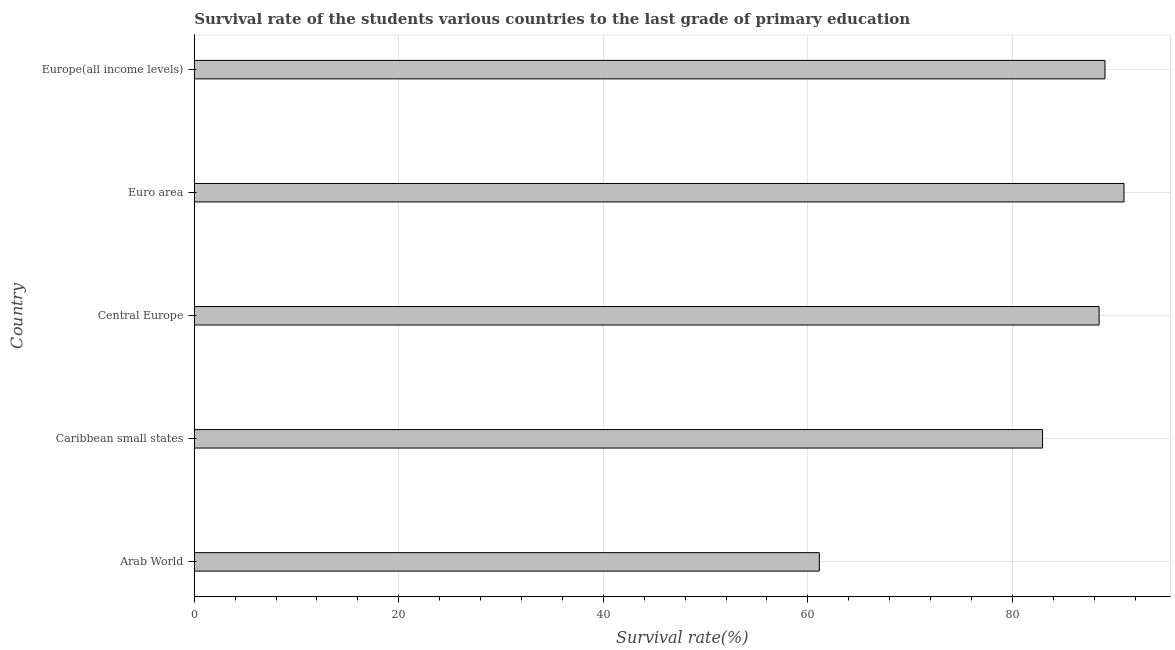Does the graph contain any zero values?
Keep it short and to the point. No. What is the title of the graph?
Provide a succinct answer. Survival rate of the students various countries to the last grade of primary education. What is the label or title of the X-axis?
Your answer should be very brief. Survival rate(%). What is the survival rate in primary education in Caribbean small states?
Ensure brevity in your answer.  82.95. Across all countries, what is the maximum survival rate in primary education?
Ensure brevity in your answer.  90.91. Across all countries, what is the minimum survival rate in primary education?
Give a very brief answer. 61.12. In which country was the survival rate in primary education minimum?
Provide a succinct answer. Arab World. What is the sum of the survival rate in primary education?
Make the answer very short. 412.5. What is the difference between the survival rate in primary education in Caribbean small states and Central Europe?
Your answer should be very brief. -5.53. What is the average survival rate in primary education per country?
Your answer should be compact. 82.5. What is the median survival rate in primary education?
Give a very brief answer. 88.48. In how many countries, is the survival rate in primary education greater than 52 %?
Your answer should be very brief. 5. What is the ratio of the survival rate in primary education in Arab World to that in Europe(all income levels)?
Provide a succinct answer. 0.69. What is the difference between the highest and the second highest survival rate in primary education?
Provide a succinct answer. 1.86. What is the difference between the highest and the lowest survival rate in primary education?
Keep it short and to the point. 29.79. What is the difference between two consecutive major ticks on the X-axis?
Your answer should be very brief. 20. What is the Survival rate(%) of Arab World?
Offer a terse response. 61.12. What is the Survival rate(%) of Caribbean small states?
Offer a terse response. 82.95. What is the Survival rate(%) of Central Europe?
Your response must be concise. 88.48. What is the Survival rate(%) in Euro area?
Give a very brief answer. 90.91. What is the Survival rate(%) in Europe(all income levels)?
Offer a terse response. 89.05. What is the difference between the Survival rate(%) in Arab World and Caribbean small states?
Make the answer very short. -21.83. What is the difference between the Survival rate(%) in Arab World and Central Europe?
Offer a terse response. -27.36. What is the difference between the Survival rate(%) in Arab World and Euro area?
Provide a succinct answer. -29.79. What is the difference between the Survival rate(%) in Arab World and Europe(all income levels)?
Provide a short and direct response. -27.93. What is the difference between the Survival rate(%) in Caribbean small states and Central Europe?
Give a very brief answer. -5.53. What is the difference between the Survival rate(%) in Caribbean small states and Euro area?
Keep it short and to the point. -7.96. What is the difference between the Survival rate(%) in Caribbean small states and Europe(all income levels)?
Give a very brief answer. -6.1. What is the difference between the Survival rate(%) in Central Europe and Euro area?
Your answer should be compact. -2.43. What is the difference between the Survival rate(%) in Central Europe and Europe(all income levels)?
Your answer should be very brief. -0.57. What is the difference between the Survival rate(%) in Euro area and Europe(all income levels)?
Provide a succinct answer. 1.86. What is the ratio of the Survival rate(%) in Arab World to that in Caribbean small states?
Your response must be concise. 0.74. What is the ratio of the Survival rate(%) in Arab World to that in Central Europe?
Give a very brief answer. 0.69. What is the ratio of the Survival rate(%) in Arab World to that in Euro area?
Offer a terse response. 0.67. What is the ratio of the Survival rate(%) in Arab World to that in Europe(all income levels)?
Make the answer very short. 0.69. What is the ratio of the Survival rate(%) in Caribbean small states to that in Central Europe?
Your answer should be very brief. 0.94. What is the ratio of the Survival rate(%) in Caribbean small states to that in Euro area?
Give a very brief answer. 0.91. What is the ratio of the Survival rate(%) in Caribbean small states to that in Europe(all income levels)?
Your response must be concise. 0.93. What is the ratio of the Survival rate(%) in Central Europe to that in Euro area?
Your answer should be very brief. 0.97. What is the ratio of the Survival rate(%) in Central Europe to that in Europe(all income levels)?
Your response must be concise. 0.99. What is the ratio of the Survival rate(%) in Euro area to that in Europe(all income levels)?
Offer a very short reply. 1.02. 